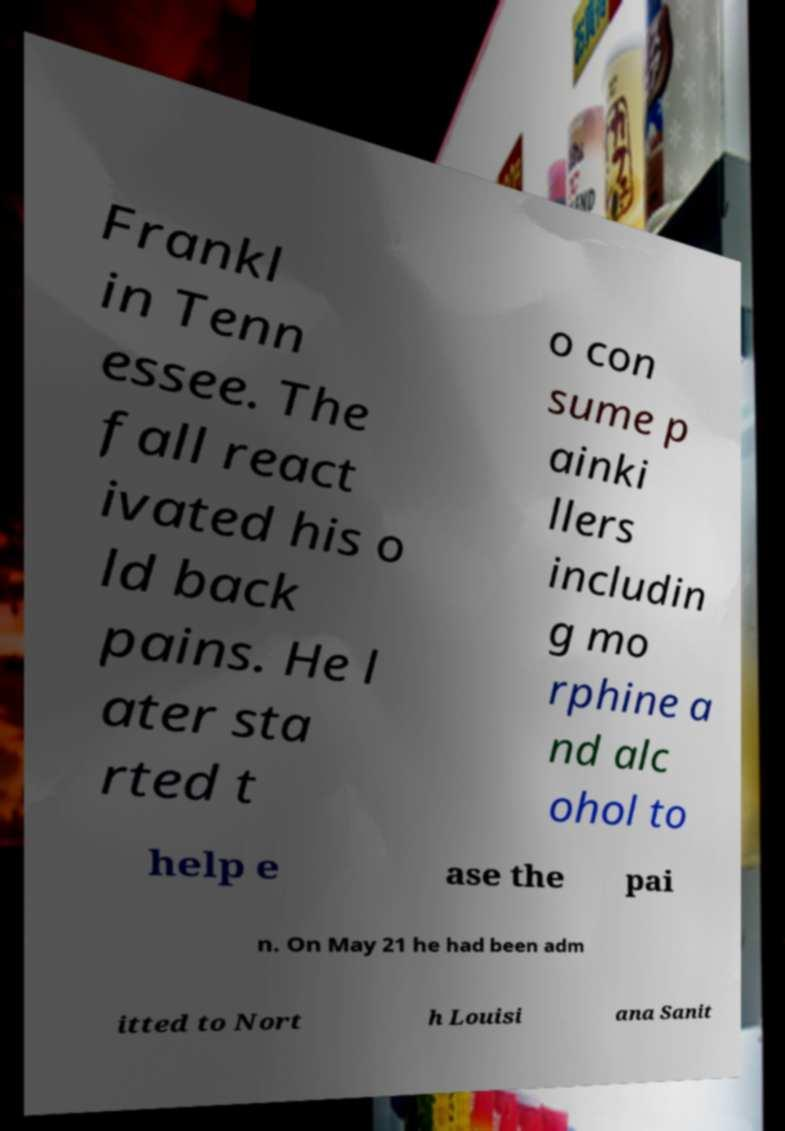Please identify and transcribe the text found in this image. Frankl in Tenn essee. The fall react ivated his o ld back pains. He l ater sta rted t o con sume p ainki llers includin g mo rphine a nd alc ohol to help e ase the pai n. On May 21 he had been adm itted to Nort h Louisi ana Sanit 